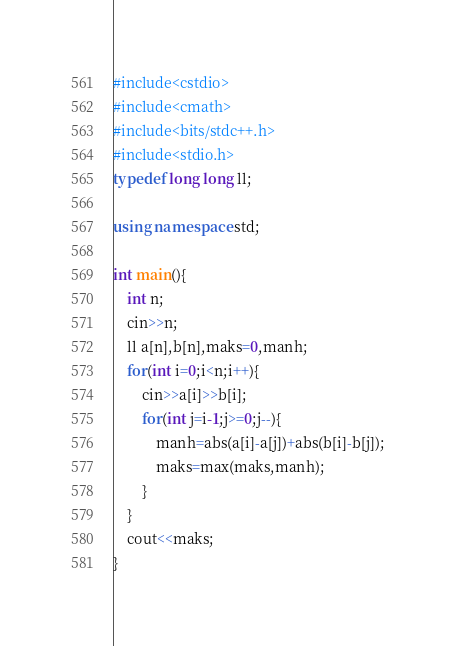Convert code to text. <code><loc_0><loc_0><loc_500><loc_500><_C++_>#include<cstdio>
#include<cmath>
#include<bits/stdc++.h>
#include<stdio.h>
typedef long long ll;

using namespace std;

int main(){
	int n;
	cin>>n;
	ll a[n],b[n],maks=0,manh;
	for(int i=0;i<n;i++){
		cin>>a[i]>>b[i];
		for(int j=i-1;j>=0;j--){
			manh=abs(a[i]-a[j])+abs(b[i]-b[j]);
			maks=max(maks,manh);
		}
	}
	cout<<maks;
}</code> 